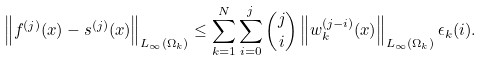Convert formula to latex. <formula><loc_0><loc_0><loc_500><loc_500>\left \| f ^ { ( j ) } ( x ) - s ^ { ( j ) } ( x ) \right \| _ { L _ { \infty } ( \Omega _ { k } ) } \leq \sum _ { k = 1 } ^ { N } \sum _ { i = 0 } ^ { j } \binom { j } { i } \left \| w _ { k } ^ { ( j - i ) } ( x ) \right \| _ { L _ { \infty } ( \Omega _ { k } ) } \epsilon _ { k } ( i ) .</formula> 